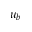Convert formula to latex. <formula><loc_0><loc_0><loc_500><loc_500>u _ { b }</formula> 